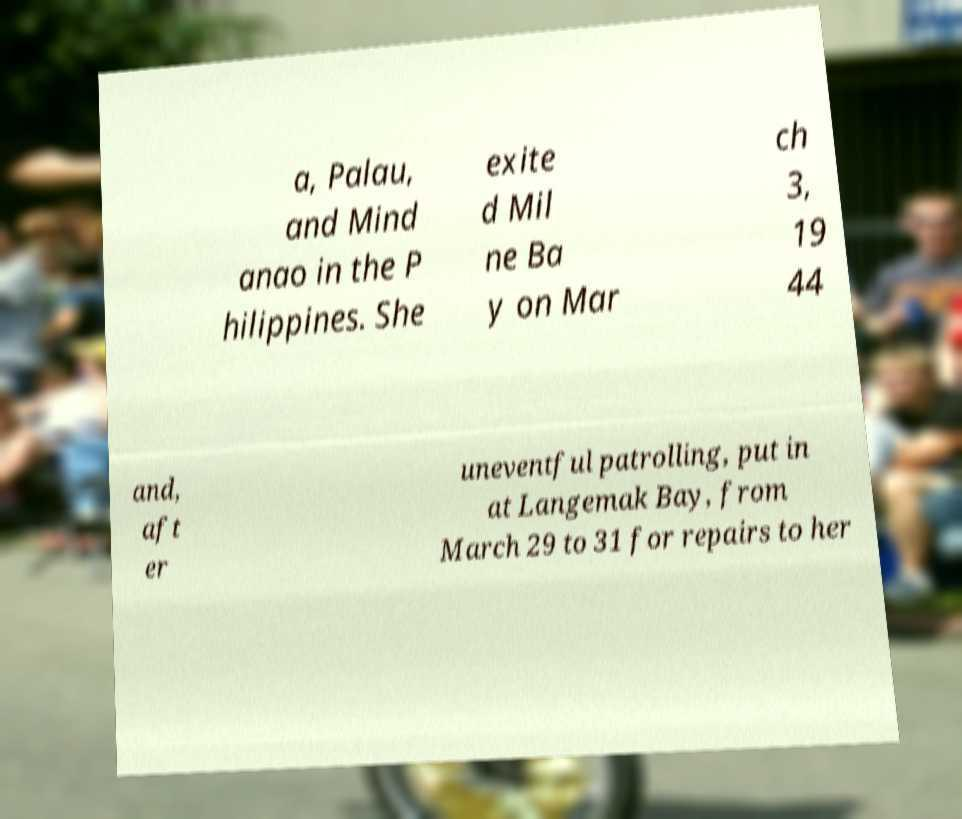Please read and relay the text visible in this image. What does it say? a, Palau, and Mind anao in the P hilippines. She exite d Mil ne Ba y on Mar ch 3, 19 44 and, aft er uneventful patrolling, put in at Langemak Bay, from March 29 to 31 for repairs to her 